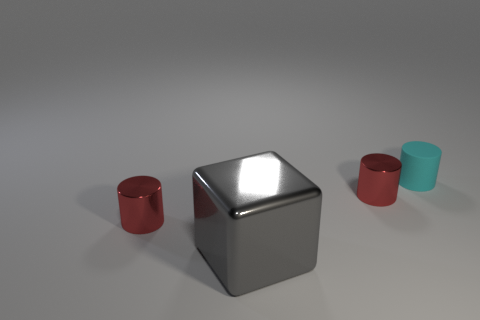Subtract all tiny red cylinders. How many cylinders are left? 1 Subtract all green balls. How many red cylinders are left? 2 Add 2 tiny cyan rubber things. How many objects exist? 6 Subtract all gray cylinders. Subtract all brown blocks. How many cylinders are left? 3 Subtract all cubes. How many objects are left? 3 Add 4 tiny cyan cylinders. How many tiny cyan cylinders exist? 5 Subtract 0 brown cylinders. How many objects are left? 4 Subtract all green rubber balls. Subtract all small cyan things. How many objects are left? 3 Add 4 small red cylinders. How many small red cylinders are left? 6 